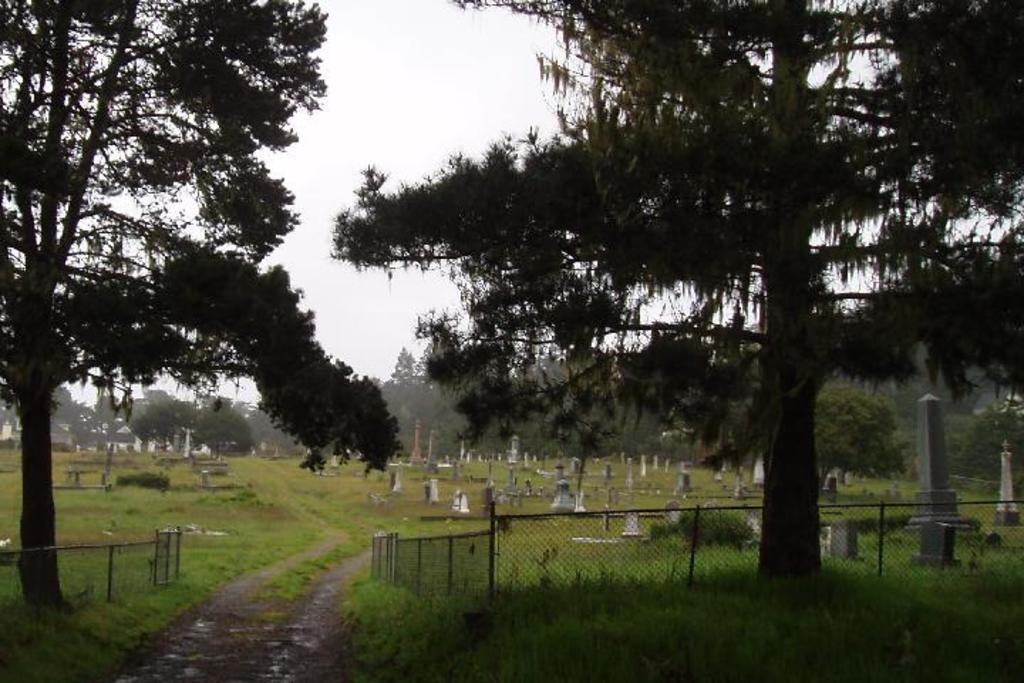Please provide a concise description of this image. This picture is clicked outside the city. In the foreground we can see the green grass, mesh, metal rods and the trees. In the center we can see the cemetery and some other objects. In the background there is a sky and the trees. 